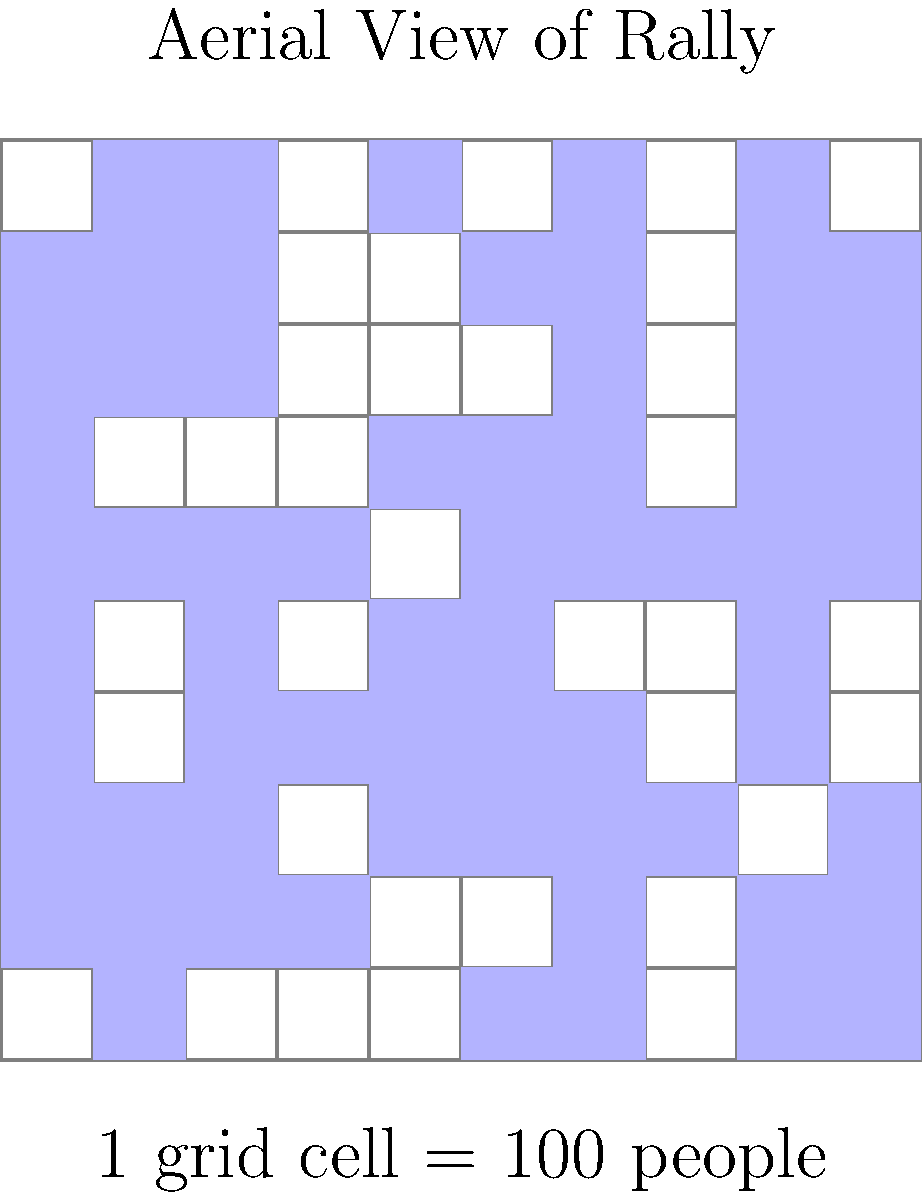Based on the aerial photograph of a rally shown above, which uses a gridded overlay where each cell represents 100 people, estimate the total crowd size. Round your answer to the nearest hundred. To estimate the crowd size, we'll follow these steps:

1. Count the number of filled (colored) cells in the grid.
2. Multiply the number of filled cells by 100 (since each cell represents 100 people).
3. Round the result to the nearest hundred.

Let's count the filled cells:

Row 1: 7 cells
Row 2: 8 cells
Row 3: 7 cells
Row 4: 6 cells
Row 5: 7 cells
Row 6: 8 cells
Row 7: 7 cells
Row 8: 6 cells
Row 9: 7 cells
Row 10: 6 cells

Total filled cells: 7 + 8 + 7 + 6 + 7 + 8 + 7 + 6 + 7 + 6 = 69 cells

Now, let's calculate the estimated crowd size:
69 cells × 100 people/cell = 6,900 people

Rounding to the nearest hundred:
6,900 rounds to 6,900

Therefore, the estimated crowd size is 6,900 people.
Answer: 6,900 people 